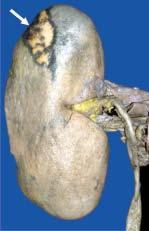does the apex lie internally?
Answer the question using a single word or phrase. Yes 